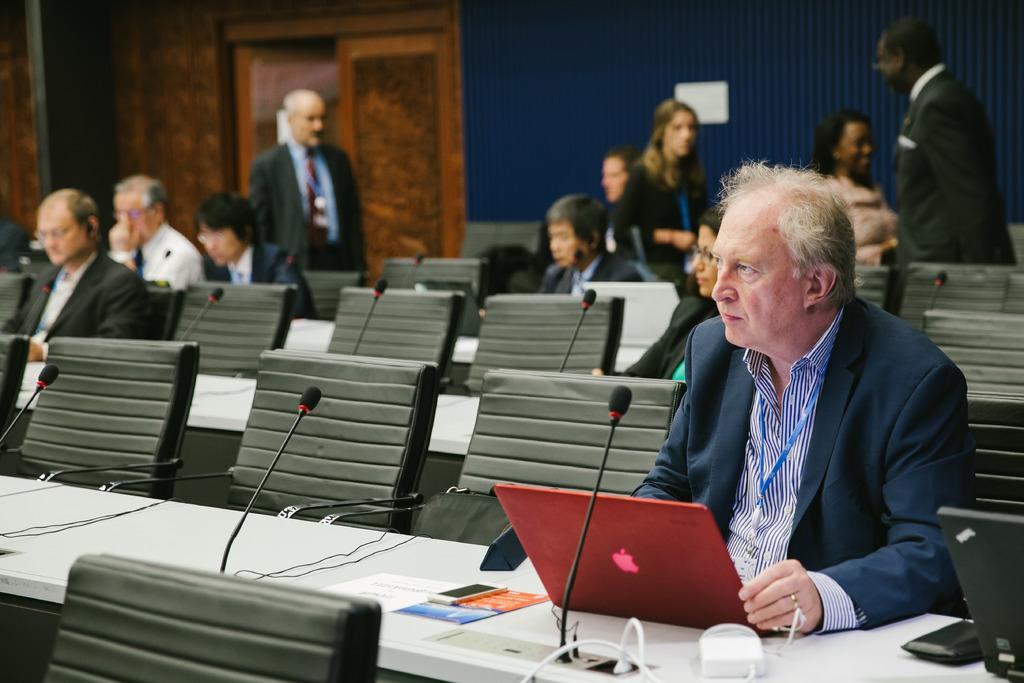What type of furniture is present in the image? There are tables and chairs in the image. What are the people in the image doing? People are sitting in the chairs. What electronic devices can be seen on the tables? There are laptops, phones, and microphones on the tables. Can you hear the harmony of the plants in the image? There are no plants present in the image, so it is not possible to hear any harmony from them. 